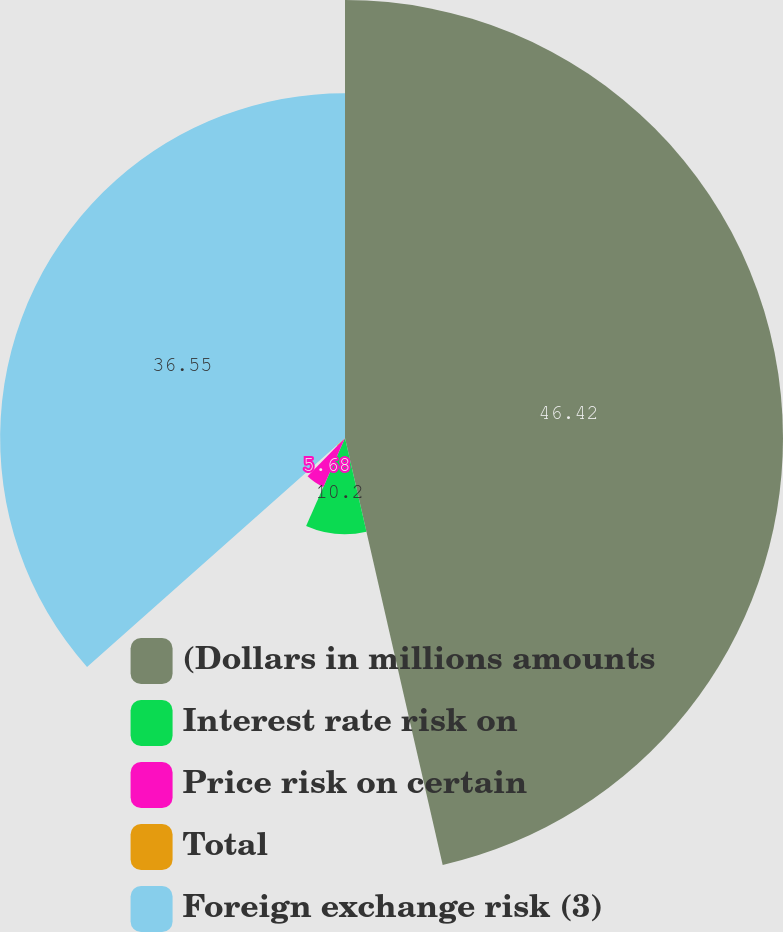<chart> <loc_0><loc_0><loc_500><loc_500><pie_chart><fcel>(Dollars in millions amounts<fcel>Interest rate risk on<fcel>Price risk on certain<fcel>Total<fcel>Foreign exchange risk (3)<nl><fcel>46.42%<fcel>10.2%<fcel>5.68%<fcel>1.15%<fcel>36.55%<nl></chart> 